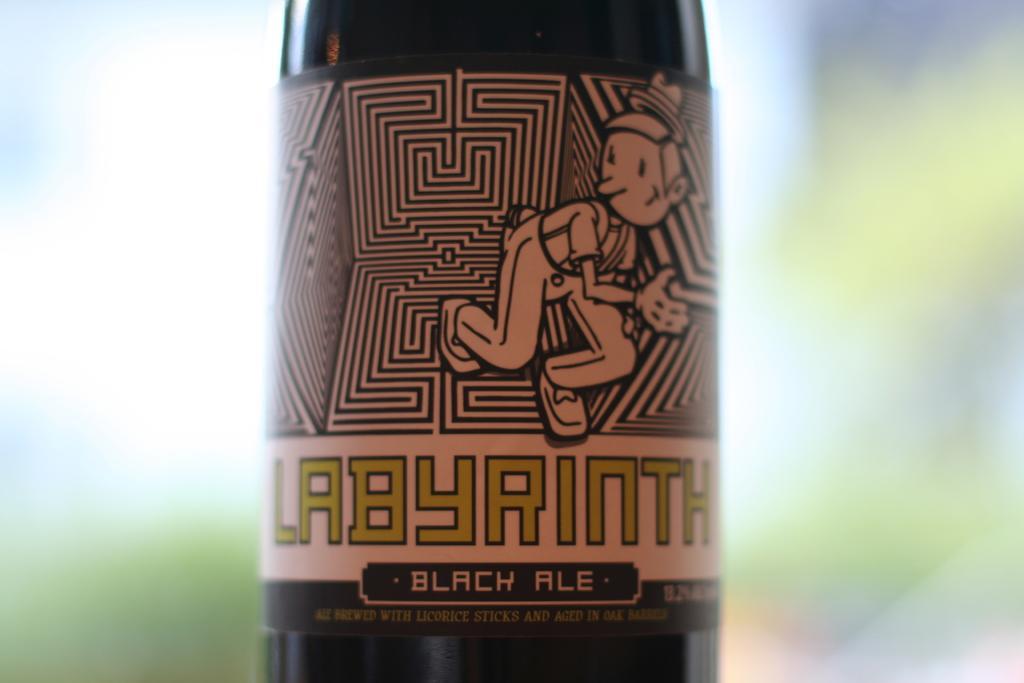In one or two sentences, can you explain what this image depicts? In this image, I can see a bottle and the background is not clear. 